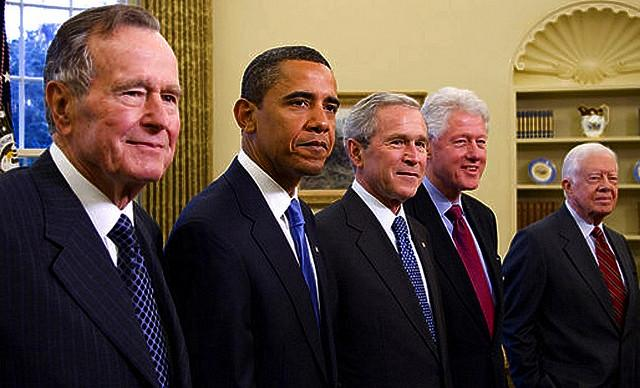What do these men have in common? Please explain your reasoning. presidency. All of them are former presidents of the united states. 